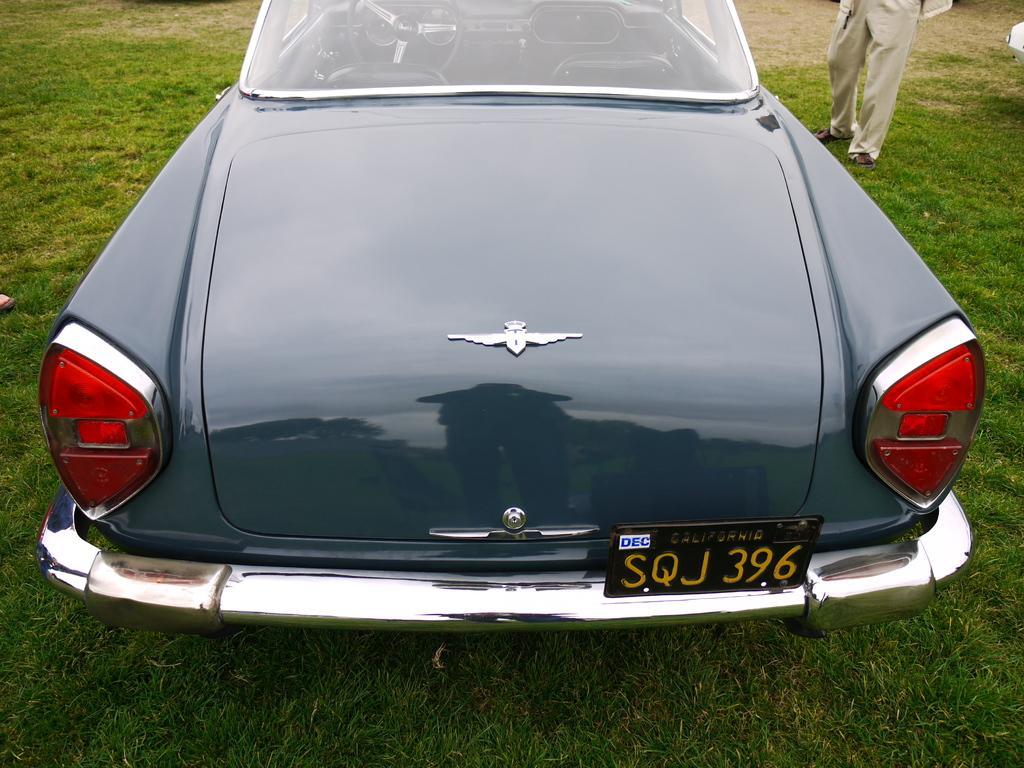Could you give a brief overview of what you see in this image? In this image there is a black color car towards the top of the image, there is a vehicle registration plate, there is text on the vehicle registration plate, there are numbers on the vehicle registration plate, there is grass towards the bottom of the image, there is a man standing towards the top of the image, there is an object towards the right of the image, there is a person's foot towards the left of the image. 